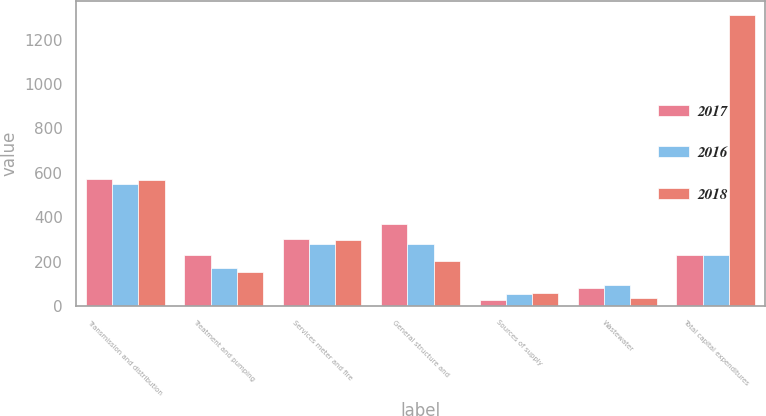<chart> <loc_0><loc_0><loc_500><loc_500><stacked_bar_chart><ecel><fcel>Transmission and distribution<fcel>Treatment and pumping<fcel>Services meter and fire<fcel>General structure and<fcel>Sources of supply<fcel>Wastewater<fcel>Total capital expenditures<nl><fcel>2017<fcel>572<fcel>231<fcel>303<fcel>371<fcel>26<fcel>83<fcel>231<nl><fcel>2016<fcel>551<fcel>171<fcel>281<fcel>281<fcel>54<fcel>96<fcel>231<nl><fcel>2018<fcel>568<fcel>151<fcel>297<fcel>202<fcel>59<fcel>34<fcel>1311<nl></chart> 